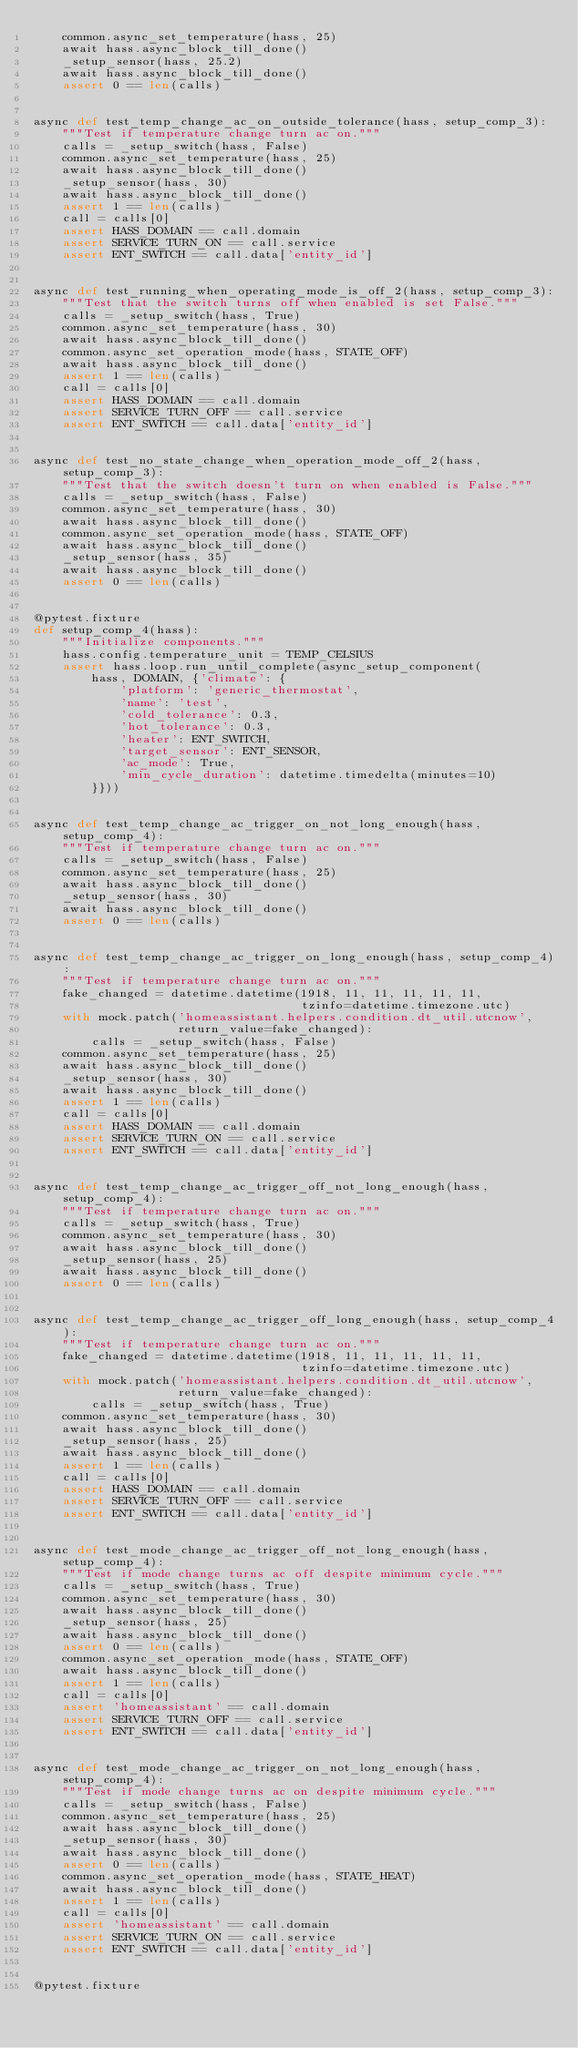<code> <loc_0><loc_0><loc_500><loc_500><_Python_>    common.async_set_temperature(hass, 25)
    await hass.async_block_till_done()
    _setup_sensor(hass, 25.2)
    await hass.async_block_till_done()
    assert 0 == len(calls)


async def test_temp_change_ac_on_outside_tolerance(hass, setup_comp_3):
    """Test if temperature change turn ac on."""
    calls = _setup_switch(hass, False)
    common.async_set_temperature(hass, 25)
    await hass.async_block_till_done()
    _setup_sensor(hass, 30)
    await hass.async_block_till_done()
    assert 1 == len(calls)
    call = calls[0]
    assert HASS_DOMAIN == call.domain
    assert SERVICE_TURN_ON == call.service
    assert ENT_SWITCH == call.data['entity_id']


async def test_running_when_operating_mode_is_off_2(hass, setup_comp_3):
    """Test that the switch turns off when enabled is set False."""
    calls = _setup_switch(hass, True)
    common.async_set_temperature(hass, 30)
    await hass.async_block_till_done()
    common.async_set_operation_mode(hass, STATE_OFF)
    await hass.async_block_till_done()
    assert 1 == len(calls)
    call = calls[0]
    assert HASS_DOMAIN == call.domain
    assert SERVICE_TURN_OFF == call.service
    assert ENT_SWITCH == call.data['entity_id']


async def test_no_state_change_when_operation_mode_off_2(hass, setup_comp_3):
    """Test that the switch doesn't turn on when enabled is False."""
    calls = _setup_switch(hass, False)
    common.async_set_temperature(hass, 30)
    await hass.async_block_till_done()
    common.async_set_operation_mode(hass, STATE_OFF)
    await hass.async_block_till_done()
    _setup_sensor(hass, 35)
    await hass.async_block_till_done()
    assert 0 == len(calls)


@pytest.fixture
def setup_comp_4(hass):
    """Initialize components."""
    hass.config.temperature_unit = TEMP_CELSIUS
    assert hass.loop.run_until_complete(async_setup_component(
        hass, DOMAIN, {'climate': {
            'platform': 'generic_thermostat',
            'name': 'test',
            'cold_tolerance': 0.3,
            'hot_tolerance': 0.3,
            'heater': ENT_SWITCH,
            'target_sensor': ENT_SENSOR,
            'ac_mode': True,
            'min_cycle_duration': datetime.timedelta(minutes=10)
        }}))


async def test_temp_change_ac_trigger_on_not_long_enough(hass, setup_comp_4):
    """Test if temperature change turn ac on."""
    calls = _setup_switch(hass, False)
    common.async_set_temperature(hass, 25)
    await hass.async_block_till_done()
    _setup_sensor(hass, 30)
    await hass.async_block_till_done()
    assert 0 == len(calls)


async def test_temp_change_ac_trigger_on_long_enough(hass, setup_comp_4):
    """Test if temperature change turn ac on."""
    fake_changed = datetime.datetime(1918, 11, 11, 11, 11, 11,
                                     tzinfo=datetime.timezone.utc)
    with mock.patch('homeassistant.helpers.condition.dt_util.utcnow',
                    return_value=fake_changed):
        calls = _setup_switch(hass, False)
    common.async_set_temperature(hass, 25)
    await hass.async_block_till_done()
    _setup_sensor(hass, 30)
    await hass.async_block_till_done()
    assert 1 == len(calls)
    call = calls[0]
    assert HASS_DOMAIN == call.domain
    assert SERVICE_TURN_ON == call.service
    assert ENT_SWITCH == call.data['entity_id']


async def test_temp_change_ac_trigger_off_not_long_enough(hass, setup_comp_4):
    """Test if temperature change turn ac on."""
    calls = _setup_switch(hass, True)
    common.async_set_temperature(hass, 30)
    await hass.async_block_till_done()
    _setup_sensor(hass, 25)
    await hass.async_block_till_done()
    assert 0 == len(calls)


async def test_temp_change_ac_trigger_off_long_enough(hass, setup_comp_4):
    """Test if temperature change turn ac on."""
    fake_changed = datetime.datetime(1918, 11, 11, 11, 11, 11,
                                     tzinfo=datetime.timezone.utc)
    with mock.patch('homeassistant.helpers.condition.dt_util.utcnow',
                    return_value=fake_changed):
        calls = _setup_switch(hass, True)
    common.async_set_temperature(hass, 30)
    await hass.async_block_till_done()
    _setup_sensor(hass, 25)
    await hass.async_block_till_done()
    assert 1 == len(calls)
    call = calls[0]
    assert HASS_DOMAIN == call.domain
    assert SERVICE_TURN_OFF == call.service
    assert ENT_SWITCH == call.data['entity_id']


async def test_mode_change_ac_trigger_off_not_long_enough(hass, setup_comp_4):
    """Test if mode change turns ac off despite minimum cycle."""
    calls = _setup_switch(hass, True)
    common.async_set_temperature(hass, 30)
    await hass.async_block_till_done()
    _setup_sensor(hass, 25)
    await hass.async_block_till_done()
    assert 0 == len(calls)
    common.async_set_operation_mode(hass, STATE_OFF)
    await hass.async_block_till_done()
    assert 1 == len(calls)
    call = calls[0]
    assert 'homeassistant' == call.domain
    assert SERVICE_TURN_OFF == call.service
    assert ENT_SWITCH == call.data['entity_id']


async def test_mode_change_ac_trigger_on_not_long_enough(hass, setup_comp_4):
    """Test if mode change turns ac on despite minimum cycle."""
    calls = _setup_switch(hass, False)
    common.async_set_temperature(hass, 25)
    await hass.async_block_till_done()
    _setup_sensor(hass, 30)
    await hass.async_block_till_done()
    assert 0 == len(calls)
    common.async_set_operation_mode(hass, STATE_HEAT)
    await hass.async_block_till_done()
    assert 1 == len(calls)
    call = calls[0]
    assert 'homeassistant' == call.domain
    assert SERVICE_TURN_ON == call.service
    assert ENT_SWITCH == call.data['entity_id']


@pytest.fixture</code> 